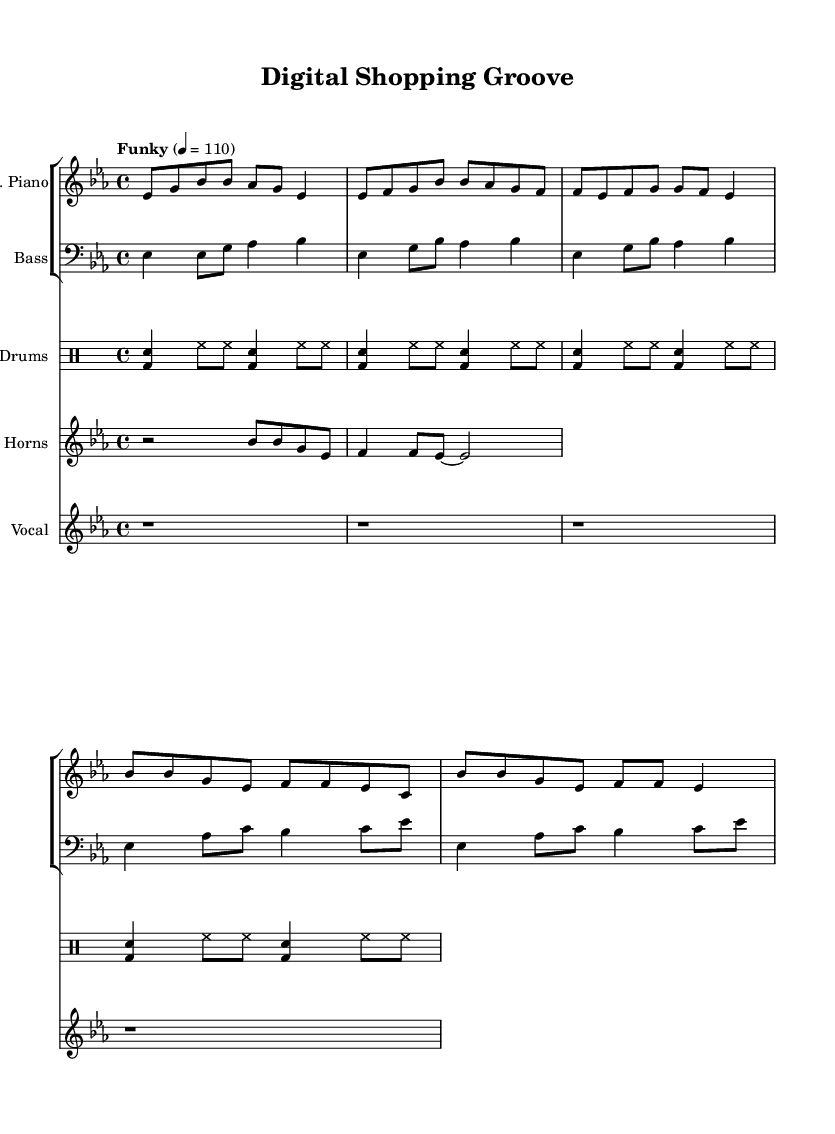What is the key signature of this music? The key signature is indicated at the beginning of the staff, which shows two flats (B and E). This corresponds to the key of E-flat major.
Answer: E-flat major What is the time signature of this music? The time signature appears in the beginning of the staff, shown as 4 over 4, which indicates that there are four beats in each measure and a quarter note gets one beat.
Answer: 4/4 What is the tempo marking for this piece? The tempo marking is found at the start of the score, stating "Funky" with a tempo of 110 beats per minute, indicating the feel and speed at which the piece should be played.
Answer: Funky 4 = 110 How many measures are in the chorus section? To find this, I can count the measures specifically in the chorus section indicated in the electric piano and bass lines. Each line contains two measures in the chorus, resulting in a total of 4 measures across both lines.
Answer: 4 What is the primary function of the horn riff in this piece? The horn riff, which appears in the chorus section, serves to add texture and emphasis to the primary melody. It plays a call-and-response pattern, enhancing the upbeat feel characteristic of funk and soul music.
Answer: Texture How does the bass pattern relate to the electric piano part? The bass pattern complements the electric piano part by reinforcing the harmonic foundation through rhythmic support. It often follows the chord changes in the electric piano while maintaining a groovy syncopation that enhances the overall feel of the music.
Answer: Complementary 